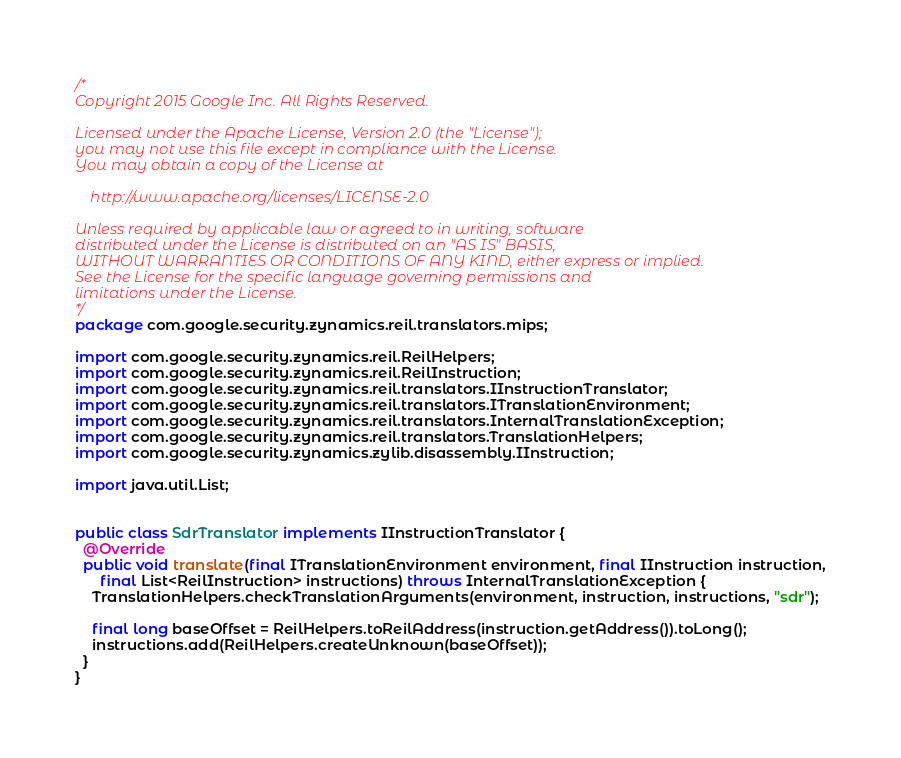<code> <loc_0><loc_0><loc_500><loc_500><_Java_>/*
Copyright 2015 Google Inc. All Rights Reserved.

Licensed under the Apache License, Version 2.0 (the "License");
you may not use this file except in compliance with the License.
You may obtain a copy of the License at

    http://www.apache.org/licenses/LICENSE-2.0

Unless required by applicable law or agreed to in writing, software
distributed under the License is distributed on an "AS IS" BASIS,
WITHOUT WARRANTIES OR CONDITIONS OF ANY KIND, either express or implied.
See the License for the specific language governing permissions and
limitations under the License.
*/
package com.google.security.zynamics.reil.translators.mips;

import com.google.security.zynamics.reil.ReilHelpers;
import com.google.security.zynamics.reil.ReilInstruction;
import com.google.security.zynamics.reil.translators.IInstructionTranslator;
import com.google.security.zynamics.reil.translators.ITranslationEnvironment;
import com.google.security.zynamics.reil.translators.InternalTranslationException;
import com.google.security.zynamics.reil.translators.TranslationHelpers;
import com.google.security.zynamics.zylib.disassembly.IInstruction;

import java.util.List;


public class SdrTranslator implements IInstructionTranslator {
  @Override
  public void translate(final ITranslationEnvironment environment, final IInstruction instruction,
      final List<ReilInstruction> instructions) throws InternalTranslationException {
    TranslationHelpers.checkTranslationArguments(environment, instruction, instructions, "sdr");

    final long baseOffset = ReilHelpers.toReilAddress(instruction.getAddress()).toLong();
    instructions.add(ReilHelpers.createUnknown(baseOffset));
  }
}
</code> 